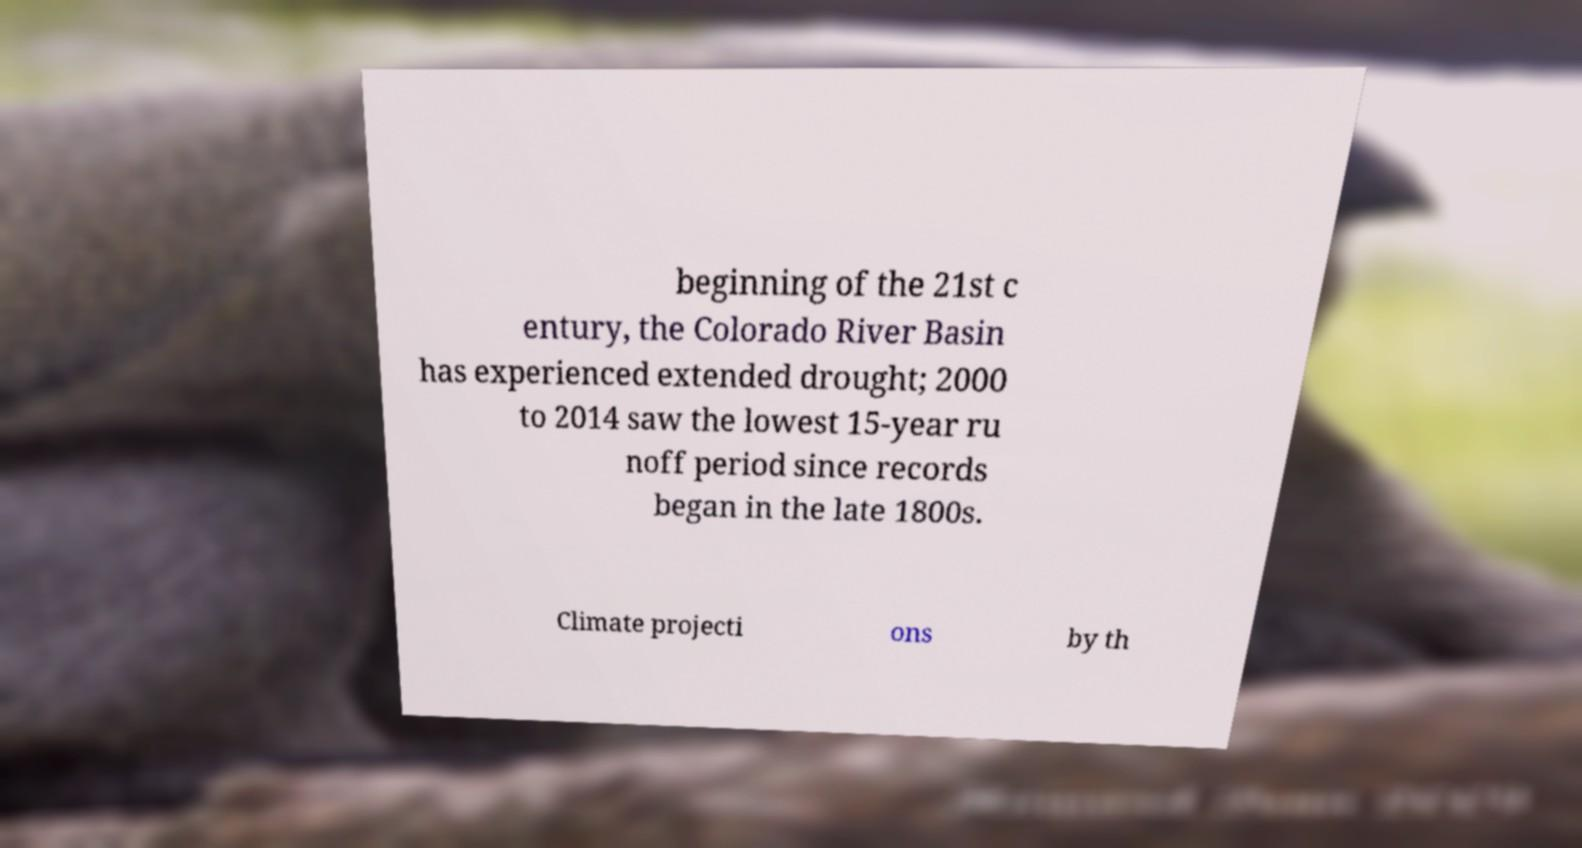I need the written content from this picture converted into text. Can you do that? beginning of the 21st c entury, the Colorado River Basin has experienced extended drought; 2000 to 2014 saw the lowest 15-year ru noff period since records began in the late 1800s. Climate projecti ons by th 